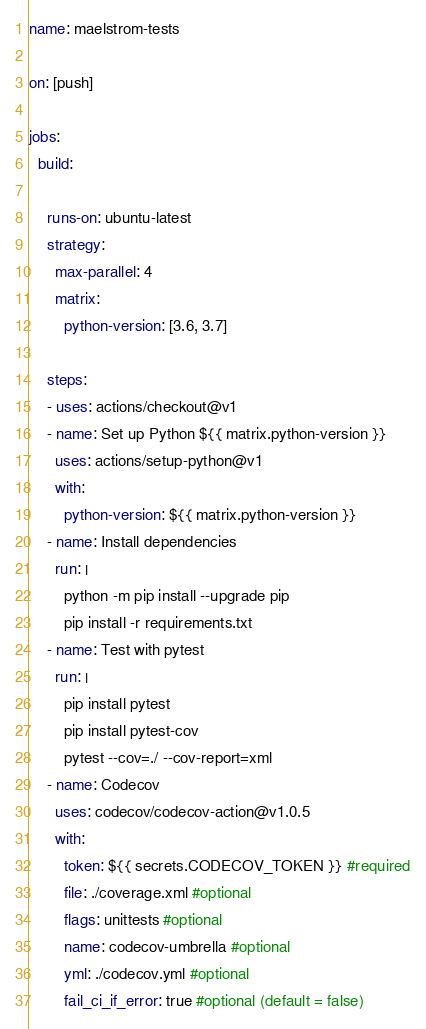Convert code to text. <code><loc_0><loc_0><loc_500><loc_500><_YAML_>name: maelstrom-tests

on: [push]

jobs:
  build:

    runs-on: ubuntu-latest
    strategy:
      max-parallel: 4
      matrix:
        python-version: [3.6, 3.7]

    steps:
    - uses: actions/checkout@v1
    - name: Set up Python ${{ matrix.python-version }}
      uses: actions/setup-python@v1
      with:
        python-version: ${{ matrix.python-version }}
    - name: Install dependencies
      run: |
        python -m pip install --upgrade pip
        pip install -r requirements.txt
    - name: Test with pytest
      run: |
        pip install pytest
        pip install pytest-cov
        pytest --cov=./ --cov-report=xml
    - name: Codecov
      uses: codecov/codecov-action@v1.0.5
      with:
        token: ${{ secrets.CODECOV_TOKEN }} #required
        file: ./coverage.xml #optional
        flags: unittests #optional
        name: codecov-umbrella #optional
        yml: ./codecov.yml #optional
        fail_ci_if_error: true #optional (default = false)
</code> 